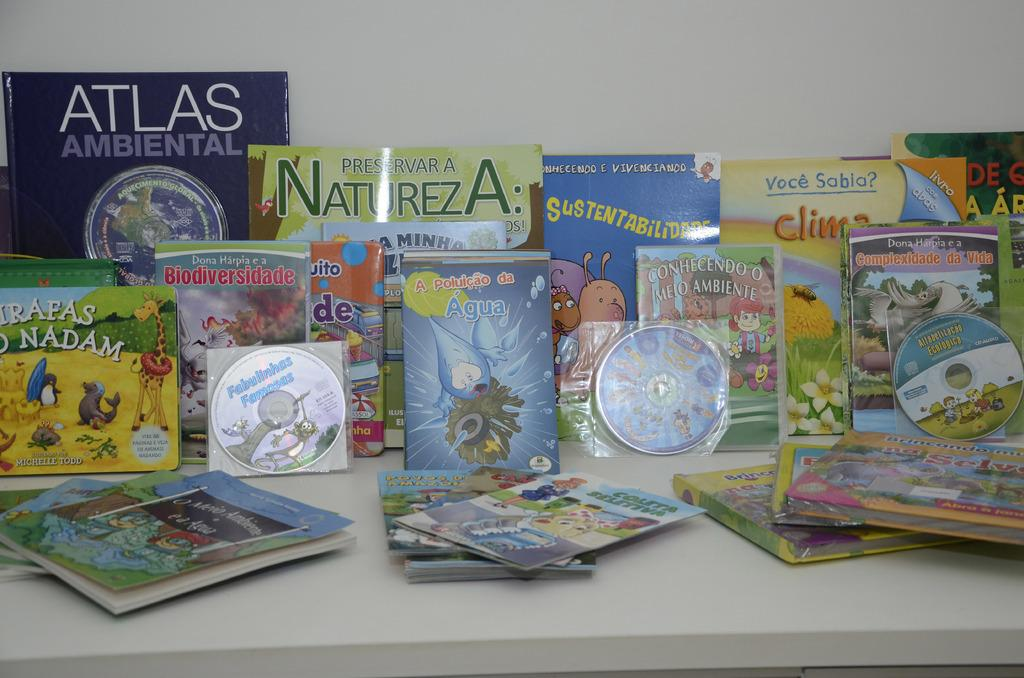<image>
Present a compact description of the photo's key features. Blue Atlas Ambiental book behind some other books on a table. 